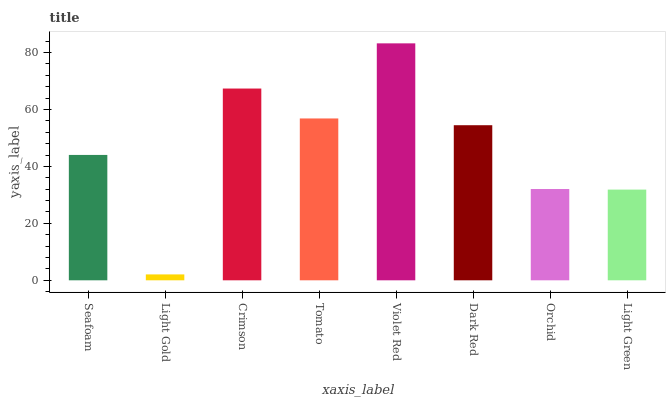Is Light Gold the minimum?
Answer yes or no. Yes. Is Violet Red the maximum?
Answer yes or no. Yes. Is Crimson the minimum?
Answer yes or no. No. Is Crimson the maximum?
Answer yes or no. No. Is Crimson greater than Light Gold?
Answer yes or no. Yes. Is Light Gold less than Crimson?
Answer yes or no. Yes. Is Light Gold greater than Crimson?
Answer yes or no. No. Is Crimson less than Light Gold?
Answer yes or no. No. Is Dark Red the high median?
Answer yes or no. Yes. Is Seafoam the low median?
Answer yes or no. Yes. Is Seafoam the high median?
Answer yes or no. No. Is Crimson the low median?
Answer yes or no. No. 